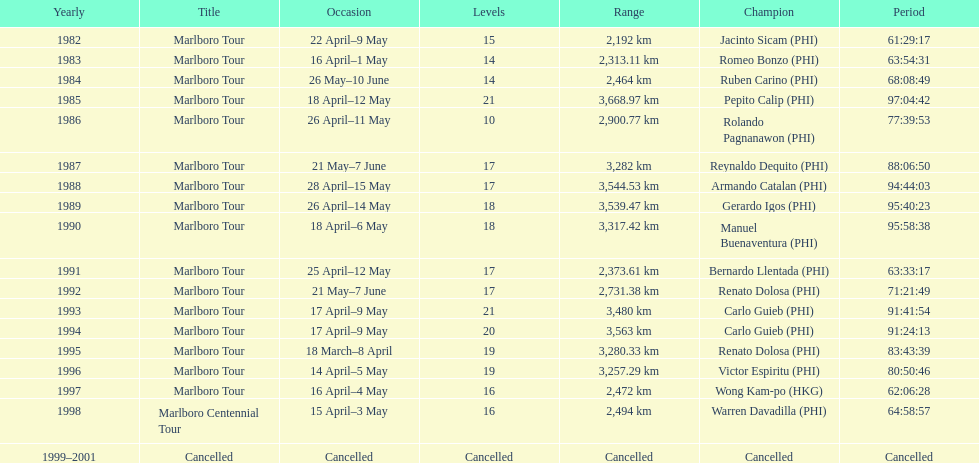What was the total number of winners before the tour was canceled? 17. 